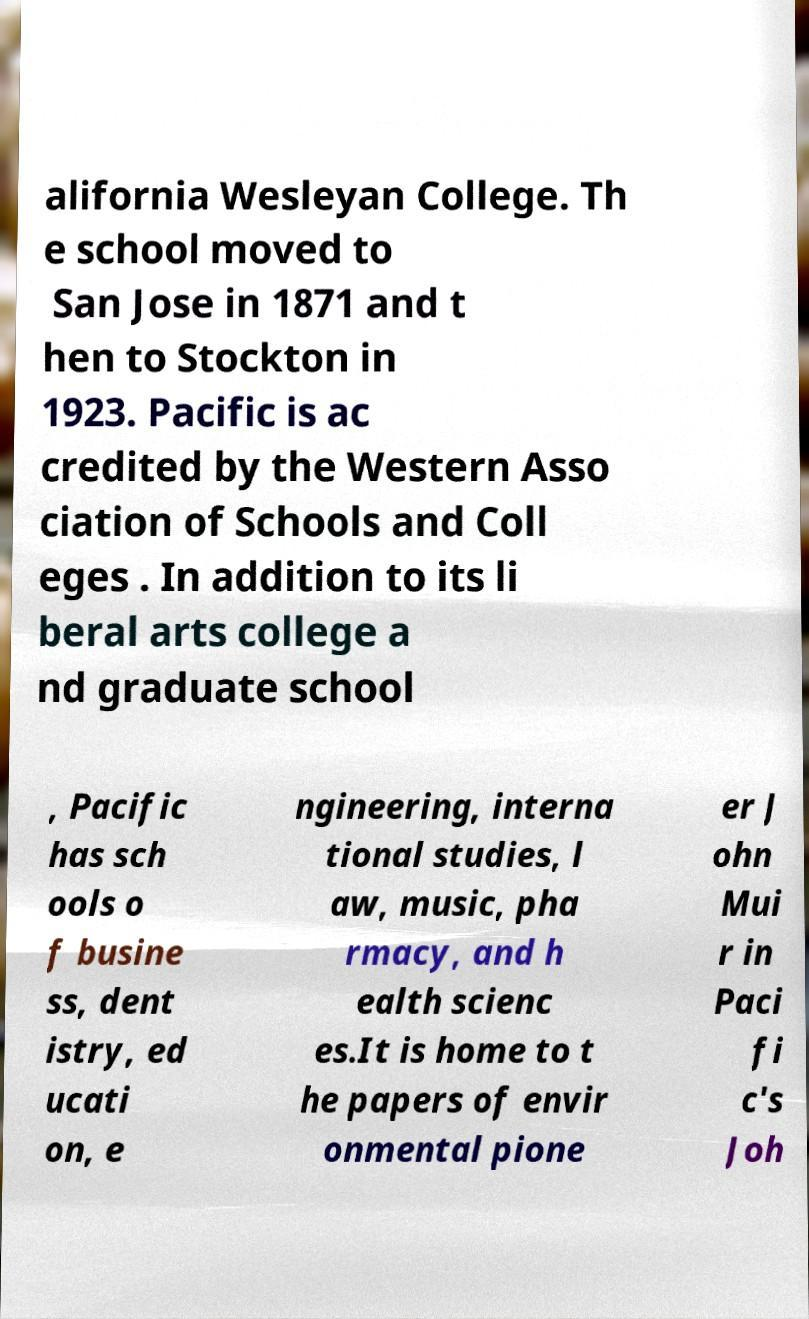For documentation purposes, I need the text within this image transcribed. Could you provide that? alifornia Wesleyan College. Th e school moved to San Jose in 1871 and t hen to Stockton in 1923. Pacific is ac credited by the Western Asso ciation of Schools and Coll eges . In addition to its li beral arts college a nd graduate school , Pacific has sch ools o f busine ss, dent istry, ed ucati on, e ngineering, interna tional studies, l aw, music, pha rmacy, and h ealth scienc es.It is home to t he papers of envir onmental pione er J ohn Mui r in Paci fi c's Joh 